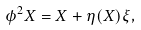Convert formula to latex. <formula><loc_0><loc_0><loc_500><loc_500>\phi ^ { 2 } X = X + \eta ( X ) \xi ,</formula> 